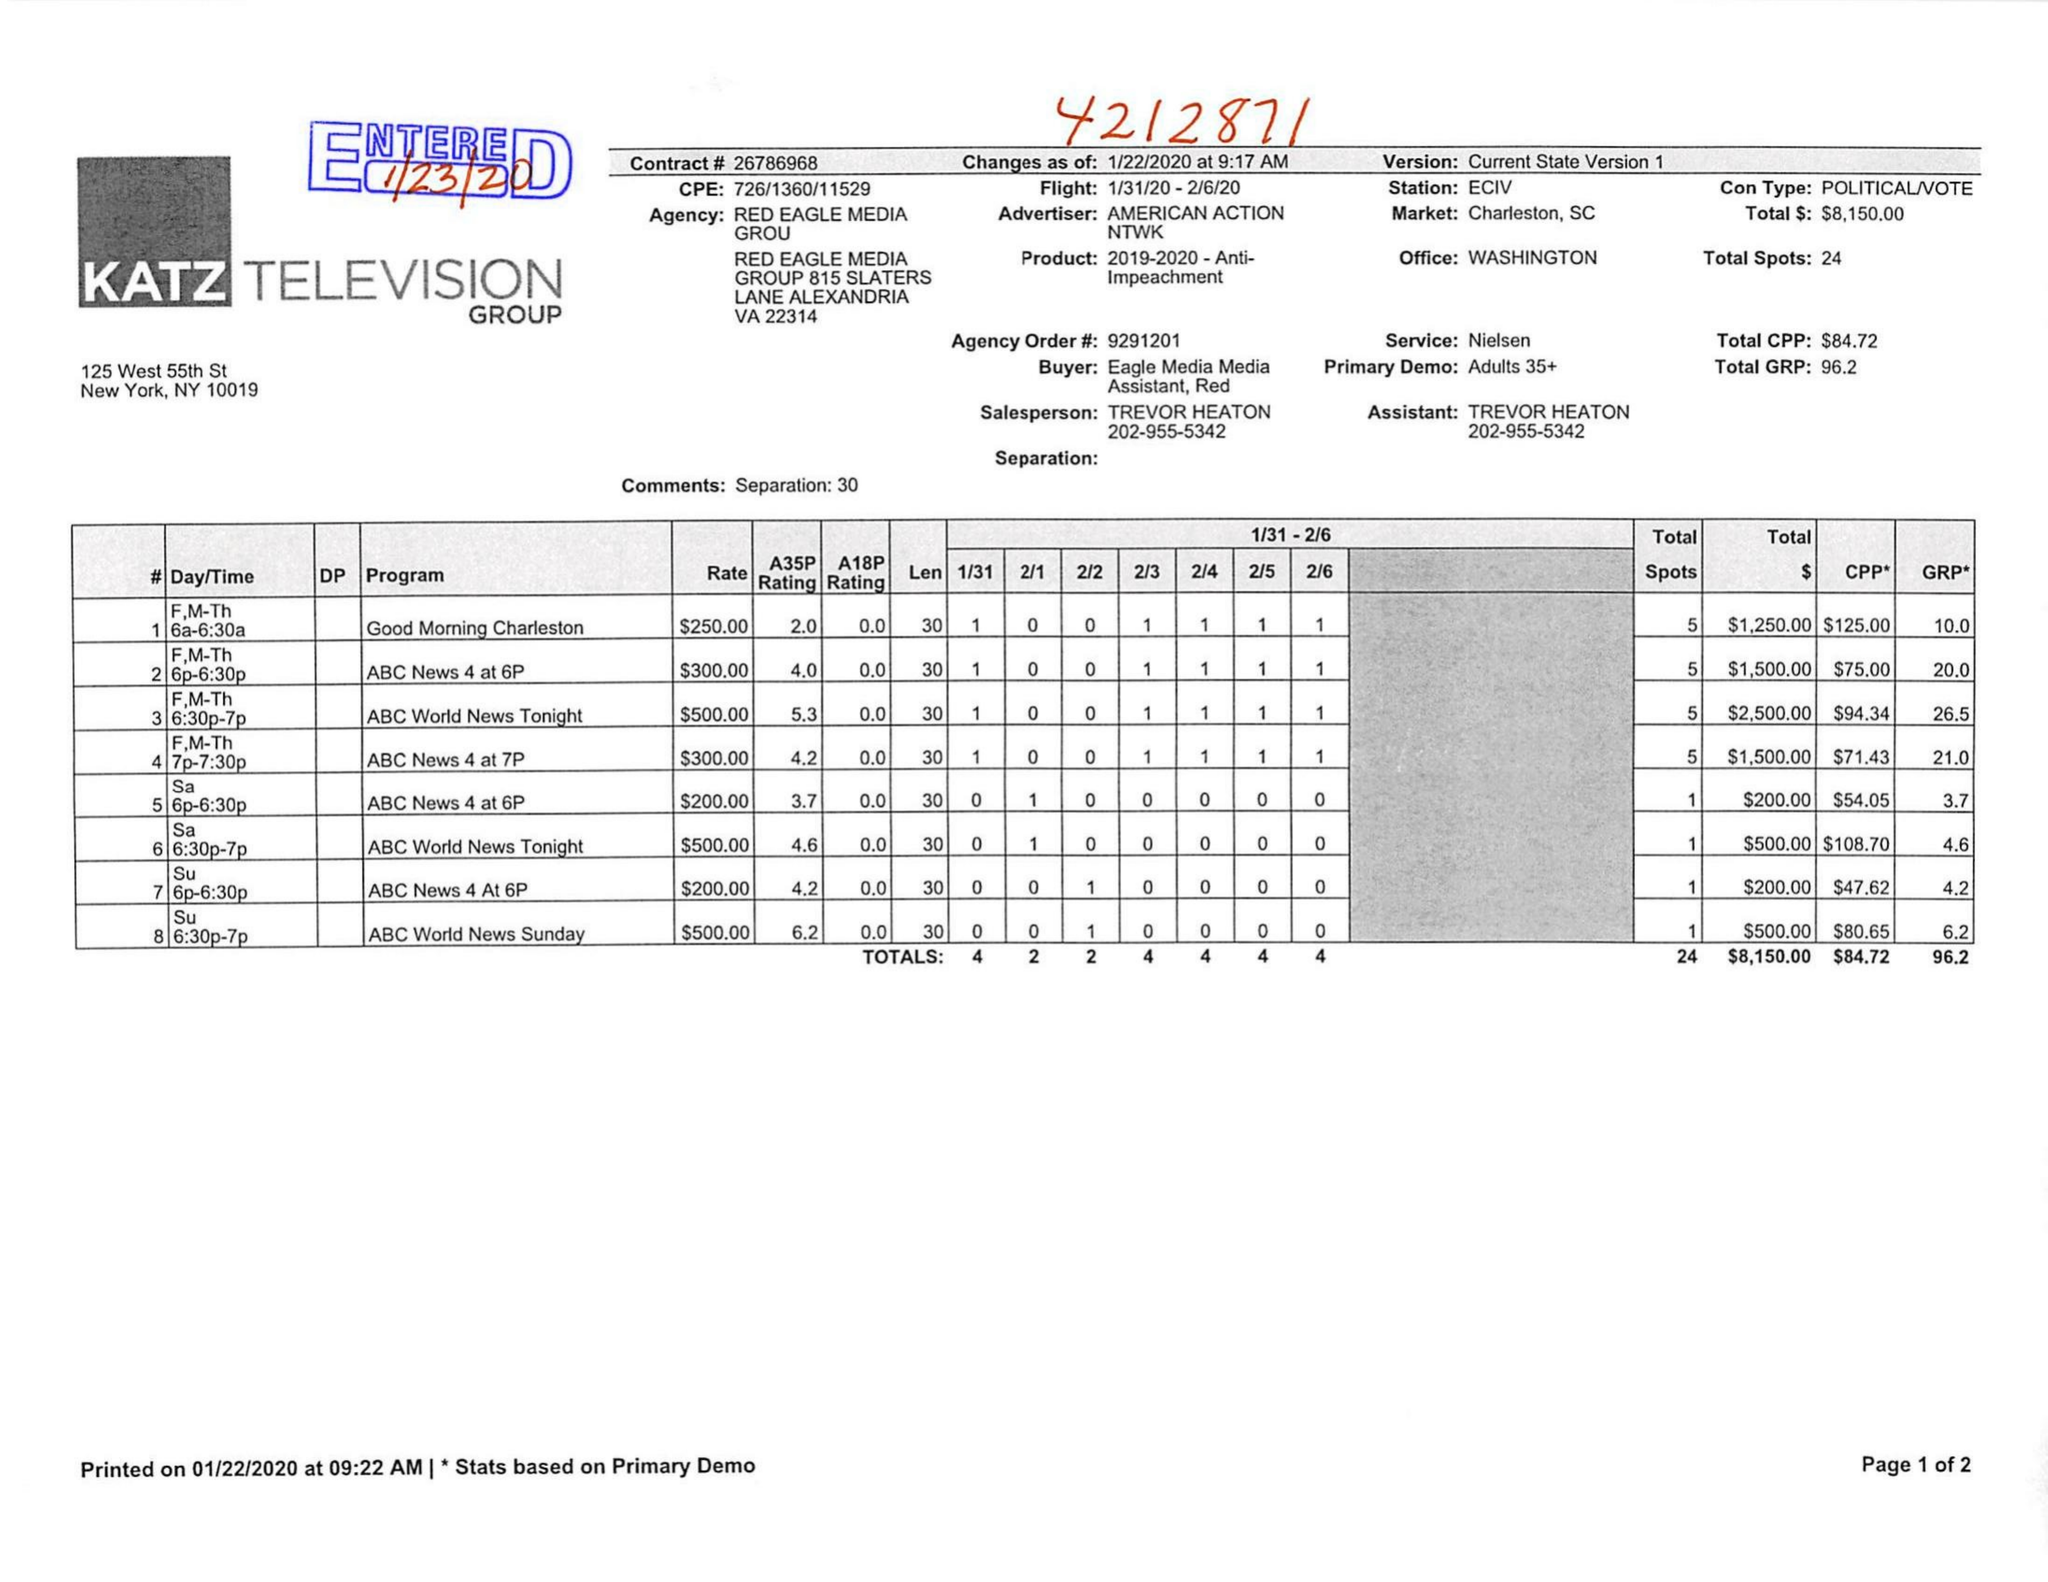What is the value for the gross_amount?
Answer the question using a single word or phrase. 8150.00 